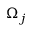Convert formula to latex. <formula><loc_0><loc_0><loc_500><loc_500>\Omega _ { j }</formula> 